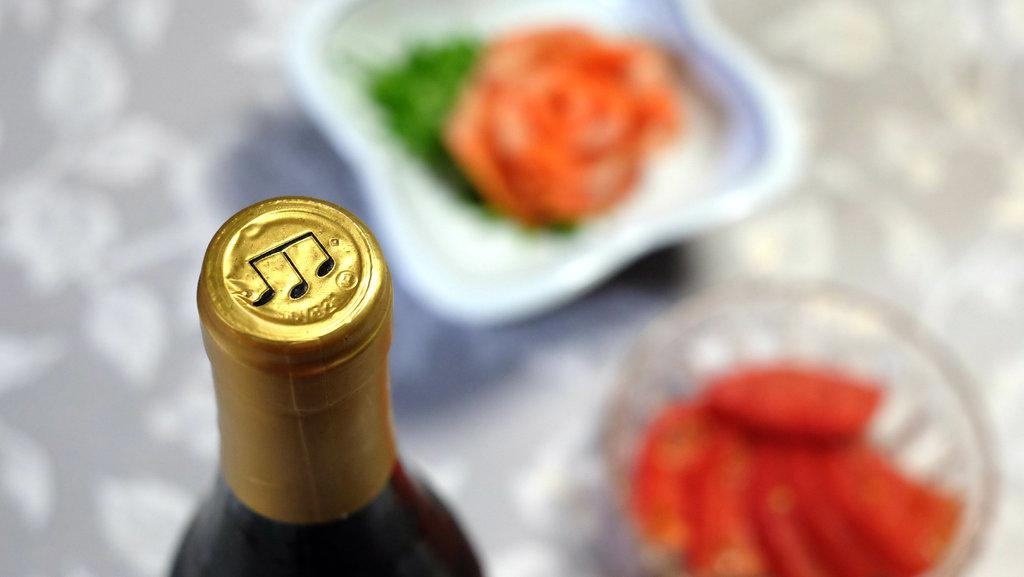What is the main object in the image? There is a bottle in the image. What else can be seen in the image besides the bottle? There are food items in bowls in the image. How many sheep are visible in the image? There are no sheep present in the image. What type of work is being done in the image? The image does not depict any work being done. 